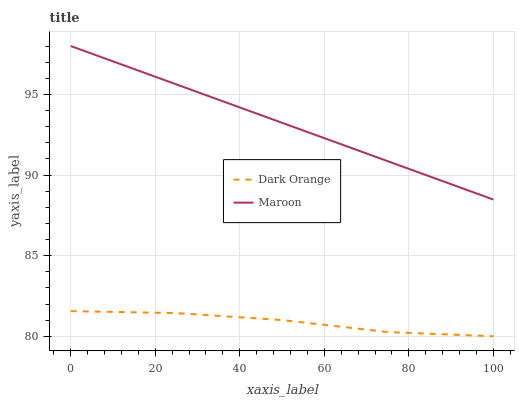Does Dark Orange have the minimum area under the curve?
Answer yes or no. Yes. Does Maroon have the maximum area under the curve?
Answer yes or no. Yes. Does Maroon have the minimum area under the curve?
Answer yes or no. No. Is Maroon the smoothest?
Answer yes or no. Yes. Is Dark Orange the roughest?
Answer yes or no. Yes. Is Maroon the roughest?
Answer yes or no. No. Does Dark Orange have the lowest value?
Answer yes or no. Yes. Does Maroon have the lowest value?
Answer yes or no. No. Does Maroon have the highest value?
Answer yes or no. Yes. Is Dark Orange less than Maroon?
Answer yes or no. Yes. Is Maroon greater than Dark Orange?
Answer yes or no. Yes. Does Dark Orange intersect Maroon?
Answer yes or no. No. 